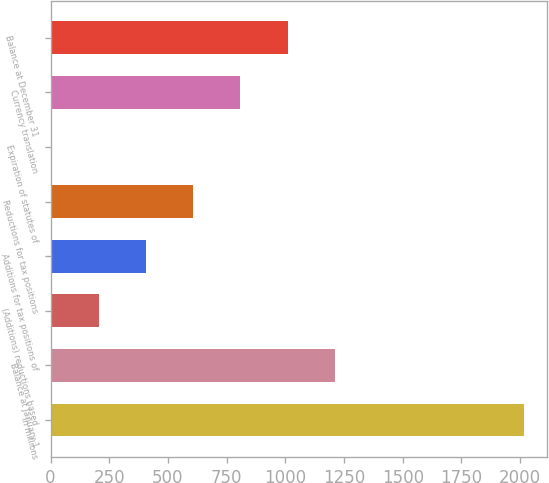Convert chart to OTSL. <chart><loc_0><loc_0><loc_500><loc_500><bar_chart><fcel>In millions<fcel>Balance at January 1<fcel>(Additions) reductions based<fcel>Additions for tax positions of<fcel>Reductions for tax positions<fcel>Expiration of statutes of<fcel>Currency translation<fcel>Balance at December 31<nl><fcel>2015<fcel>1210.6<fcel>205.1<fcel>406.2<fcel>607.3<fcel>4<fcel>808.4<fcel>1009.5<nl></chart> 